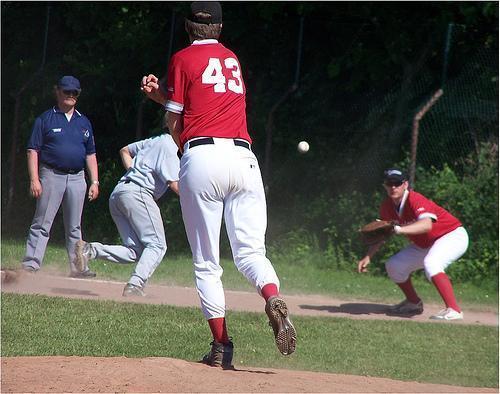How many people are in the photo?
Give a very brief answer. 4. How many objects on the window sill over the sink are made to hold coffee?
Give a very brief answer. 0. 